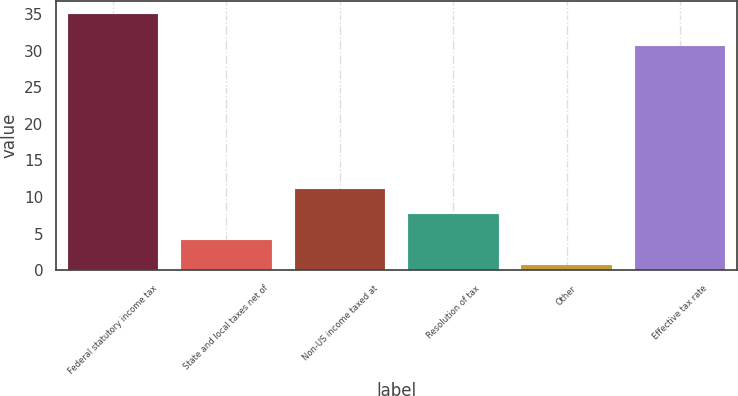<chart> <loc_0><loc_0><loc_500><loc_500><bar_chart><fcel>Federal statutory income tax<fcel>State and local taxes net of<fcel>Non-US income taxed at<fcel>Resolution of tax<fcel>Other<fcel>Effective tax rate<nl><fcel>35<fcel>4.22<fcel>11.06<fcel>7.64<fcel>0.8<fcel>30.6<nl></chart> 